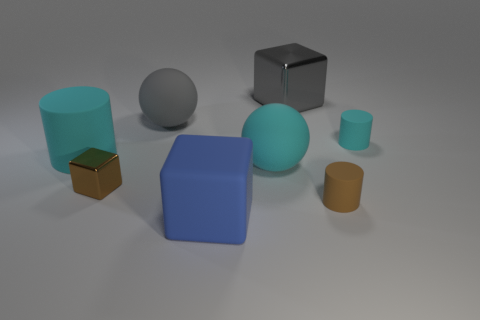Subtract all small shiny blocks. How many blocks are left? 2 Subtract all gray balls. How many balls are left? 1 Add 1 cyan metallic spheres. How many objects exist? 9 Subtract all cylinders. How many objects are left? 5 Subtract 1 spheres. How many spheres are left? 1 Subtract all cyan cubes. Subtract all yellow spheres. How many cubes are left? 3 Subtract all red cubes. How many gray spheres are left? 1 Subtract all small purple metallic things. Subtract all cyan spheres. How many objects are left? 7 Add 1 brown shiny things. How many brown shiny things are left? 2 Add 1 brown shiny objects. How many brown shiny objects exist? 2 